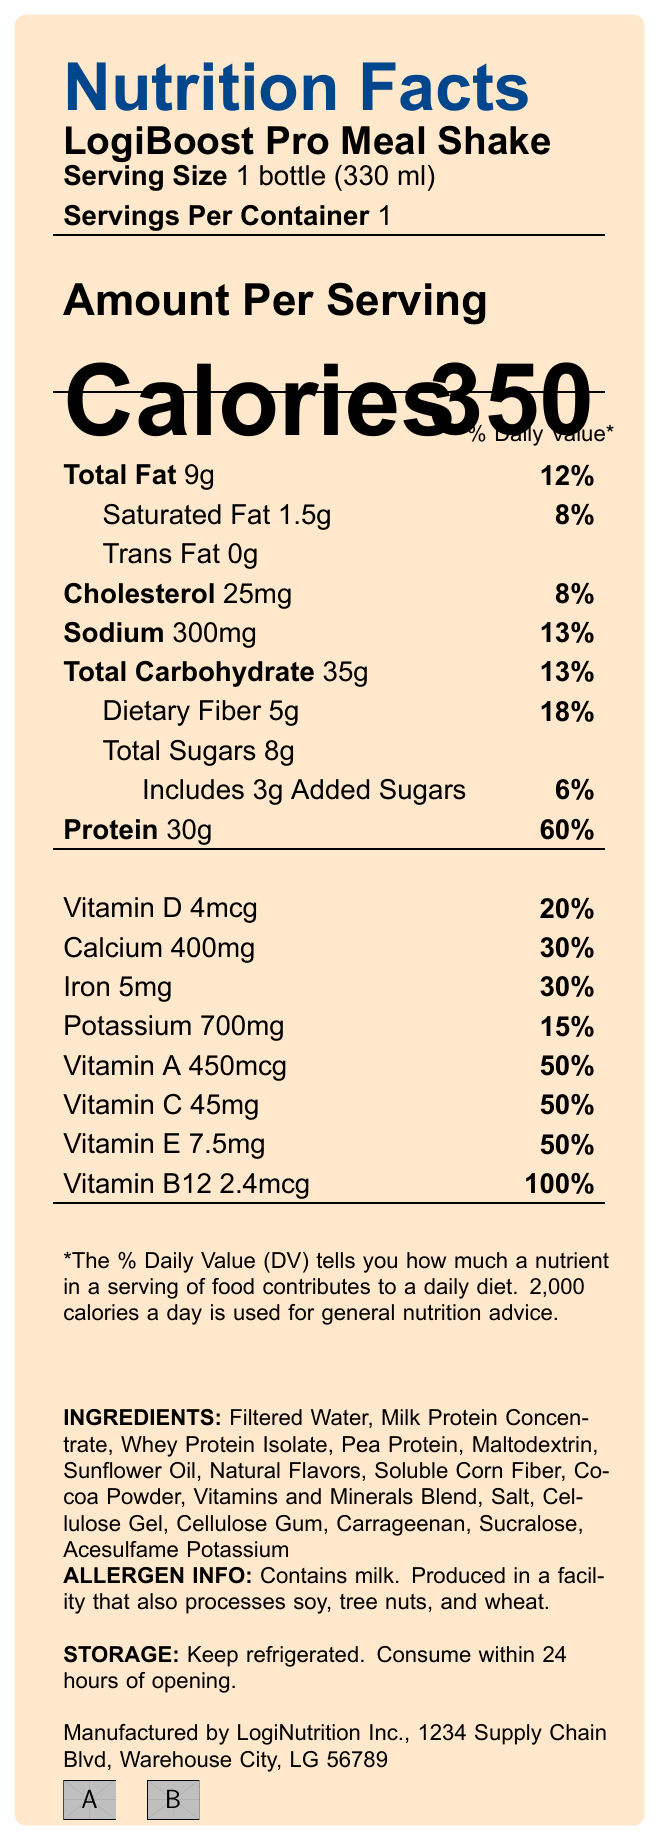what is the serving size of the LogiBoost Pro Meal Shake? The serving size is listed at the top of the document under the product name and servings per container.
Answer: 1 bottle (330 ml) how many calories are in one serving of the LogiBoost Pro Meal Shake? The amount is prominently displayed next to the word "Calories" in the document.
Answer: 350 calories what is the percentage of the daily value of protein in the LogiBoost Pro Meal Shake? This percentage is listed next to the protein content in the nutrition facts section.
Answer: 60% how much total fat is in a single serving? The amount is found directly in the nutrition facts under "Total Fat".
Answer: 9g what are the main ingredients in the LogiBoost Pro Meal Shake? These are listed in the ingredients section at the bottom of the document.
Answer: Filtered Water, Milk Protein Concentrate, Whey Protein Isolate, Pea Protein, Maltodextrin, Sunflower Oil, Natural Flavors, Soluble Corn Fiber, Cocoa Powder, Vitamins and Minerals Blend, Salt, Cellulose Gel, Cellulose Gum, Carrageenan, Sucralose, Acesulfame Potassium which vitamin has the highest percentage of daily value in one serving of the shake? A. Vitamin D, B. Calcium, C. Vitamin B12, D. Iron Vitamin B12 has a percentage of 100%, which is higher than the other listed vitamins and minerals.
Answer: C. Vitamin B12 what is the percentage daily value of dietary fiber per serving? A. 6%, B. 8%, C. 13%, D. 18% The percentage is shown next to dietary fiber in the nutrition facts.
Answer: D. 18% does the LogiBoost Pro Meal Shake contain any trans fat? The nutrition facts list the trans fat content as 0g.
Answer: No is the LogiBoost Pro Meal Shake non-GMO? It contains the Non-GMO Project Verified certification listed at the bottom of the document.
Answer: Yes what are the allergen warnings for the LogiBoost Pro Meal Shake? This information is found under the allergen info section in the document.
Answer: Contains milk. Produced in a facility that also processes soy, tree nuts, and wheat. describe the main purpose and contents of the LogiBoost Pro Meal Shake nutrition facts label. The document presents a comprehensive overview of the product's nutritional value, intended users, and additional relevant information to help consumers make informed decisions about using the shake.
Answer: The LogiBoost Pro Meal Shake nutrition facts label provides detailed information about the nutritional content, ingredients, allergen warnings, and storage instructions of the meal replacement shake. It is designed for logistics workers on-the-go and is high in protein to support muscle health. The label lists various vitamins and minerals percentages, total fat, carbohydrates, added sugars, and more. It also includes marketing claims and certifications such as Non-GMO and Kosher. how much calcium is in one serving of the LogiBoost Pro Meal Shake? This amount is listed under the vitamins and minerals section of the nutritional facts.
Answer: 400mg where is the LogiBoost Pro Meal Shake manufactured? This information is found towards the bottom of the document under manufacturer info.
Answer: LogiNutrition Inc., 1234 Supply Chain Blvd, Warehouse City, LG 56789 does the document specify the price of the LogiBoost Pro Meal Shake? The document does not contain any pricing details.
Answer: Not enough information what are the storage instructions for the LogiBoost Pro Meal Shake? This information is provided in the storage section at the bottom of the document.
Answer: Keep refrigerated. Consume within 24 hours of opening. 